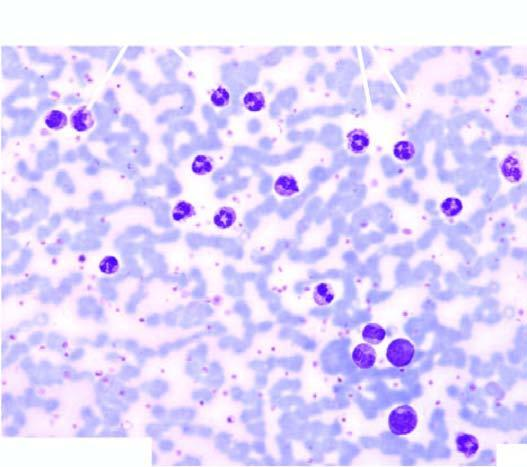what is accompanied with late precursors of myeloid series?
Answer the question using a single word or phrase. Peripheral blood film showing marked neutrophilic leucocytosis 